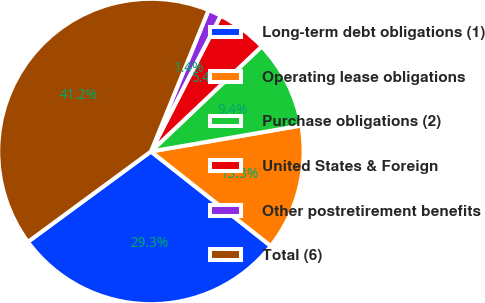<chart> <loc_0><loc_0><loc_500><loc_500><pie_chart><fcel>Long-term debt obligations (1)<fcel>Operating lease obligations<fcel>Purchase obligations (2)<fcel>United States & Foreign<fcel>Other postretirement benefits<fcel>Total (6)<nl><fcel>29.29%<fcel>13.35%<fcel>9.36%<fcel>5.37%<fcel>1.39%<fcel>41.25%<nl></chart> 